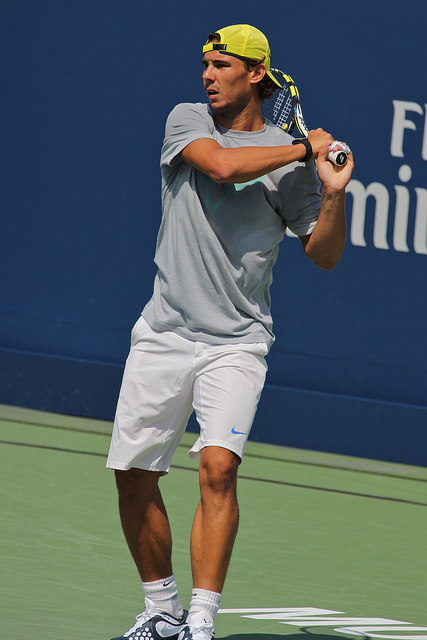<image>What brand of sneakers is he wearing? I can't tell what brand of sneakers he is wearing. It can be Nike or Puma. What brand of sneakers is he wearing? It is not clear what brand of sneakers he is wearing. However, it can be seen that he is wearing Nike sneakers. 